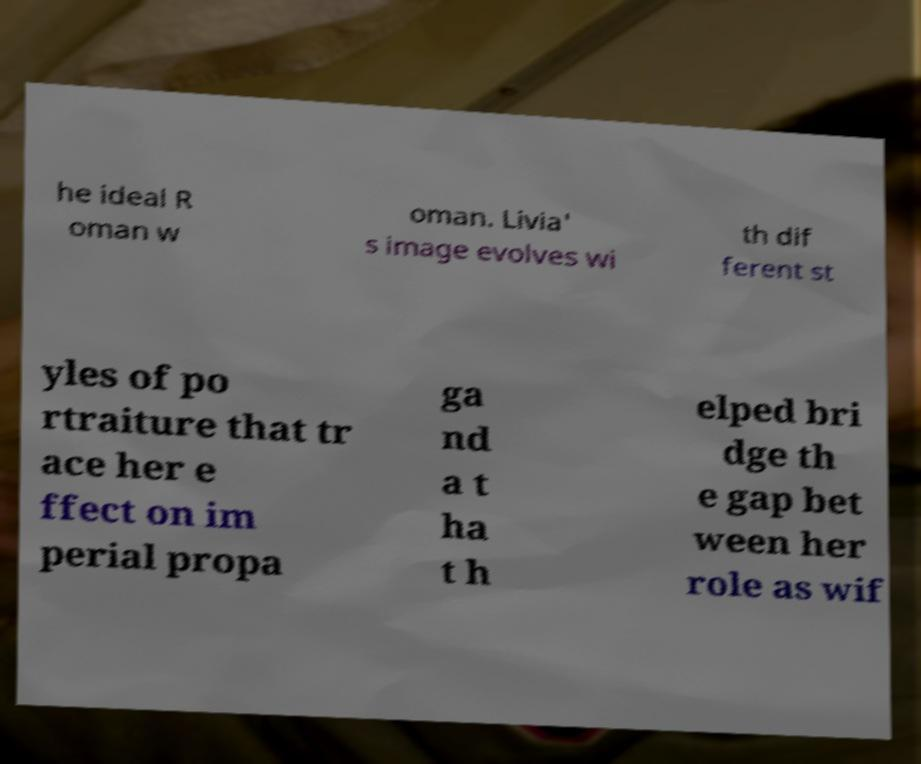Please identify and transcribe the text found in this image. he ideal R oman w oman. Livia' s image evolves wi th dif ferent st yles of po rtraiture that tr ace her e ffect on im perial propa ga nd a t ha t h elped bri dge th e gap bet ween her role as wif 